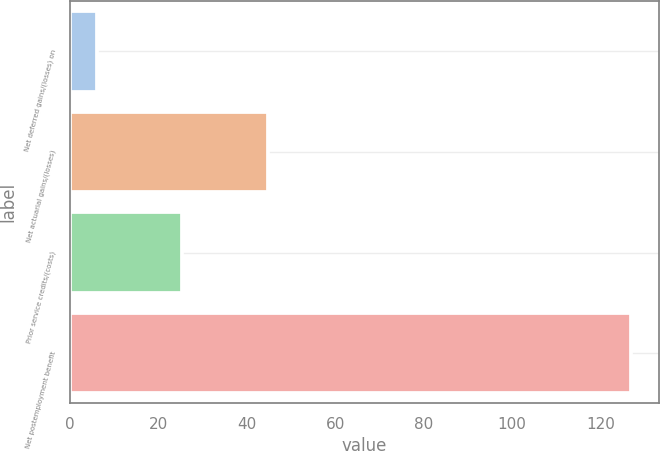Convert chart to OTSL. <chart><loc_0><loc_0><loc_500><loc_500><bar_chart><fcel>Net deferred gains/(losses) on<fcel>Net actuarial gains/(losses)<fcel>Prior service credits/(costs)<fcel>Net postemployment benefit<nl><fcel>6<fcel>44.8<fcel>25.4<fcel>127<nl></chart> 